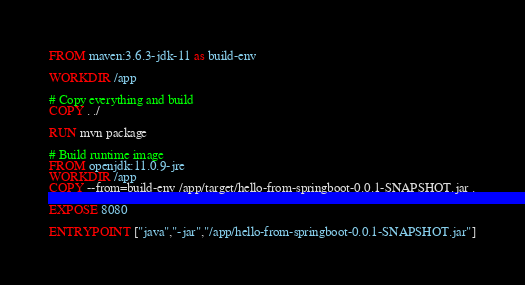<code> <loc_0><loc_0><loc_500><loc_500><_Dockerfile_>FROM maven:3.6.3-jdk-11 as build-env

WORKDIR /app

# Copy everything and build
COPY . ./

RUN mvn package

# Build runtime image
FROM openjdk:11.0.9-jre
WORKDIR /app
COPY --from=build-env /app/target/hello-from-springboot-0.0.1-SNAPSHOT.jar .

EXPOSE 8080

ENTRYPOINT ["java","-jar","/app/hello-from-springboot-0.0.1-SNAPSHOT.jar"]
</code> 